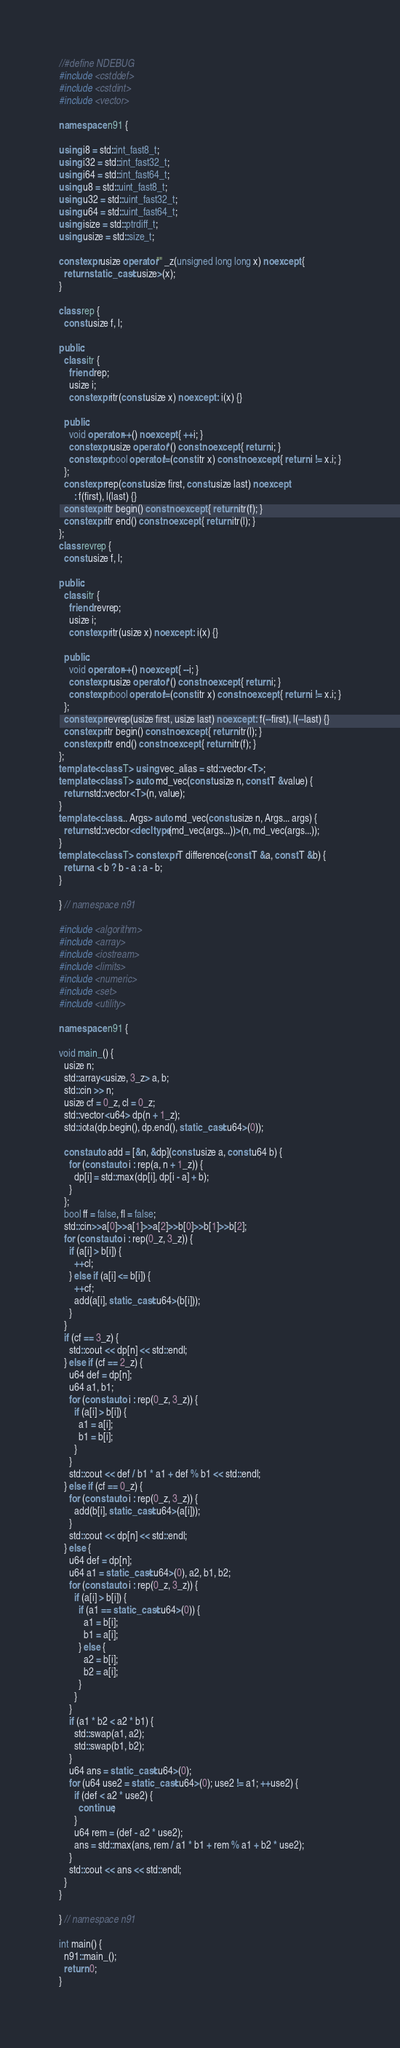<code> <loc_0><loc_0><loc_500><loc_500><_C++_>//#define NDEBUG
#include <cstddef>
#include <cstdint>
#include <vector>

namespace n91 {

using i8 = std::int_fast8_t;
using i32 = std::int_fast32_t;
using i64 = std::int_fast64_t;
using u8 = std::uint_fast8_t;
using u32 = std::uint_fast32_t;
using u64 = std::uint_fast64_t;
using isize = std::ptrdiff_t;
using usize = std::size_t;

constexpr usize operator"" _z(unsigned long long x) noexcept {
  return static_cast<usize>(x);
}

class rep {
  const usize f, l;

public:
  class itr {
    friend rep;
    usize i;
    constexpr itr(const usize x) noexcept : i(x) {}

  public:
    void operator++() noexcept { ++i; }
    constexpr usize operator*() const noexcept { return i; }
    constexpr bool operator!=(const itr x) const noexcept { return i != x.i; }
  };
  constexpr rep(const usize first, const usize last) noexcept
      : f(first), l(last) {}
  constexpr itr begin() const noexcept { return itr(f); }
  constexpr itr end() const noexcept { return itr(l); }
};
class revrep {
  const usize f, l;

public:
  class itr {
    friend revrep;
    usize i;
    constexpr itr(usize x) noexcept : i(x) {}

  public:
    void operator++() noexcept { --i; }
    constexpr usize operator*() const noexcept { return i; }
    constexpr bool operator!=(const itr x) const noexcept { return i != x.i; }
  };
  constexpr revrep(usize first, usize last) noexcept : f(--first), l(--last) {}
  constexpr itr begin() const noexcept { return itr(l); }
  constexpr itr end() const noexcept { return itr(f); }
};
template <class T> using vec_alias = std::vector<T>;
template <class T> auto md_vec(const usize n, const T &value) {
  return std::vector<T>(n, value);
}
template <class... Args> auto md_vec(const usize n, Args... args) {
  return std::vector<decltype(md_vec(args...))>(n, md_vec(args...));
}
template <class T> constexpr T difference(const T &a, const T &b) {
  return a < b ? b - a : a - b;
}

} // namespace n91

#include <algorithm>
#include <array>
#include <iostream>
#include <limits>
#include <numeric>
#include <set>
#include <utility>

namespace n91 {

void main_() {
  usize n;
  std::array<usize, 3_z> a, b;
  std::cin >> n;
  usize cf = 0_z, cl = 0_z;
  std::vector<u64> dp(n + 1_z);
  std::iota(dp.begin(), dp.end(), static_cast<u64>(0));

  const auto add = [&n, &dp](const usize a, const u64 b) {
    for (const auto i : rep(a, n + 1_z)) {
      dp[i] = std::max(dp[i], dp[i - a] + b);
    }
  };
  bool ff = false, fl = false;
  std::cin>>a[0]>>a[1]>>a[2]>>b[0]>>b[1]>>b[2];
  for (const auto i : rep(0_z, 3_z)) {
    if (a[i] > b[i]) {
      ++cl;
    } else if (a[i] <= b[i]) {
      ++cf;
      add(a[i], static_cast<u64>(b[i]));
    }
  }
  if (cf == 3_z) {
    std::cout << dp[n] << std::endl;
  } else if (cf == 2_z) {
    u64 def = dp[n];
    u64 a1, b1;
    for (const auto i : rep(0_z, 3_z)) {
      if (a[i] > b[i]) {
        a1 = a[i];
        b1 = b[i];
      }
    }
    std::cout << def / b1 * a1 + def % b1 << std::endl;
  } else if (cf == 0_z) {
    for (const auto i : rep(0_z, 3_z)) {
      add(b[i], static_cast<u64>(a[i]));
    }
    std::cout << dp[n] << std::endl;
  } else {
    u64 def = dp[n];
    u64 a1 = static_cast<u64>(0), a2, b1, b2;
    for (const auto i : rep(0_z, 3_z)) {
      if (a[i] > b[i]) {
        if (a1 == static_cast<u64>(0)) {
          a1 = b[i];
          b1 = a[i];
        } else {
          a2 = b[i];
          b2 = a[i];
        }
      }
    }
    if (a1 * b2 < a2 * b1) {
      std::swap(a1, a2);
      std::swap(b1, b2);
    }
    u64 ans = static_cast<u64>(0);
    for (u64 use2 = static_cast<u64>(0); use2 != a1; ++use2) {
      if (def < a2 * use2) {
        continue;
      }
      u64 rem = (def - a2 * use2);
      ans = std::max(ans, rem / a1 * b1 + rem % a1 + b2 * use2);
    }
    std::cout << ans << std::endl;
  }
}

} // namespace n91

int main() {
  n91::main_();
  return 0;
}
</code> 